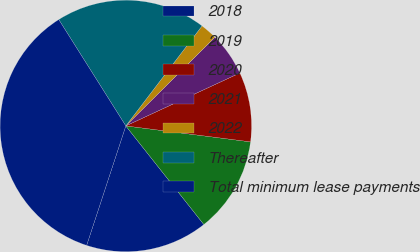Convert chart to OTSL. <chart><loc_0><loc_0><loc_500><loc_500><pie_chart><fcel>2018<fcel>2019<fcel>2020<fcel>2021<fcel>2022<fcel>Thereafter<fcel>Total minimum lease payments<nl><fcel>15.7%<fcel>12.32%<fcel>8.94%<fcel>5.55%<fcel>2.17%<fcel>19.32%<fcel>36.01%<nl></chart> 